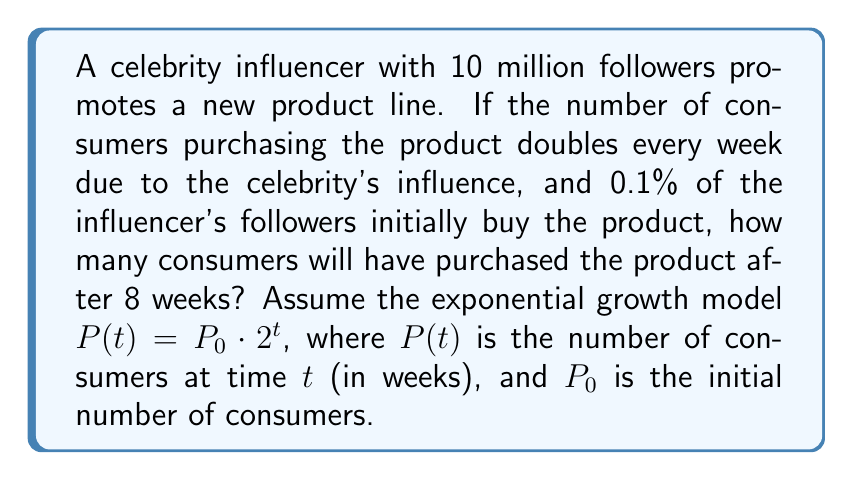Provide a solution to this math problem. To solve this problem, we'll use the exponential growth model $P(t) = P_0 \cdot 2^t$, where:

$P(t)$ = number of consumers at time $t$ (in weeks)
$P_0$ = initial number of consumers
$t$ = time in weeks

Step 1: Calculate the initial number of consumers ($P_0$)
$P_0 = 0.1\% \text{ of } 10 \text{ million followers}$
$P_0 = 0.001 \times 10,000,000 = 10,000$

Step 2: Set up the exponential growth equation
$P(t) = 10,000 \cdot 2^t$

Step 3: Calculate the number of consumers after 8 weeks by substituting $t = 8$
$P(8) = 10,000 \cdot 2^8$

Step 4: Evaluate the expression
$P(8) = 10,000 \cdot 256 = 2,560,000$

Therefore, after 8 weeks, 2,560,000 consumers will have purchased the product.
Answer: 2,560,000 consumers 